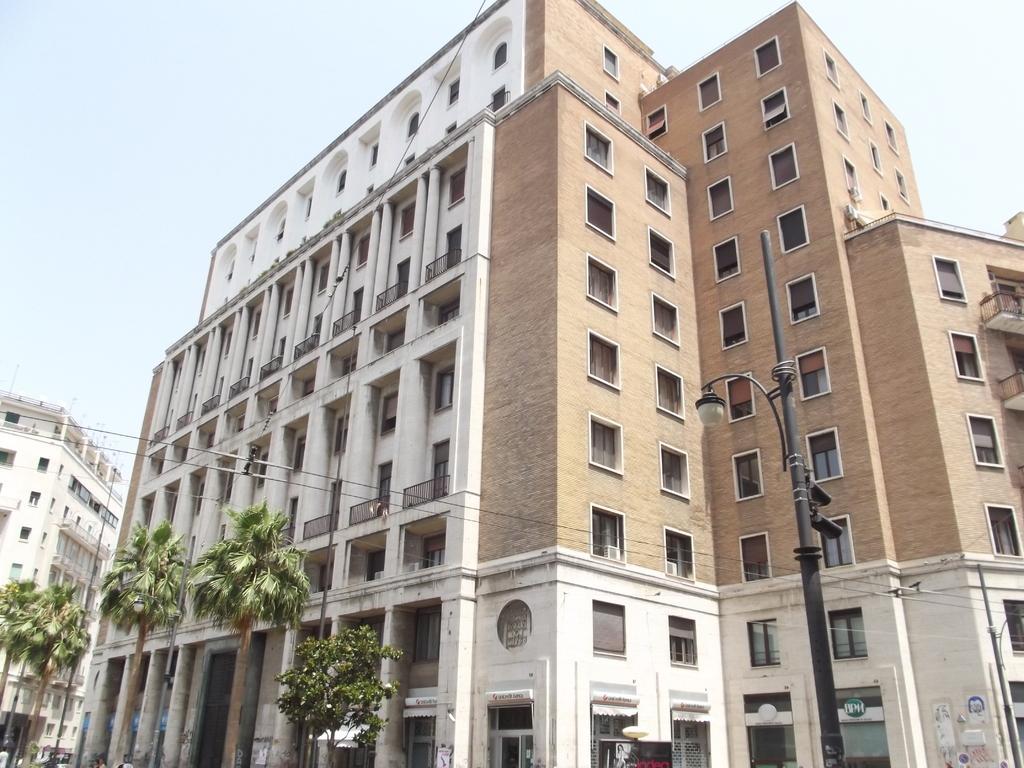Could you give a brief overview of what you see in this image? In this picture I can observe buildings. On the right side I can observe pole. In front of the buildings I can observe trees. In the background I can observe sky. 